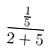Convert formula to latex. <formula><loc_0><loc_0><loc_500><loc_500>\frac { \frac { 1 } { 5 } } { 2 + 5 }</formula> 